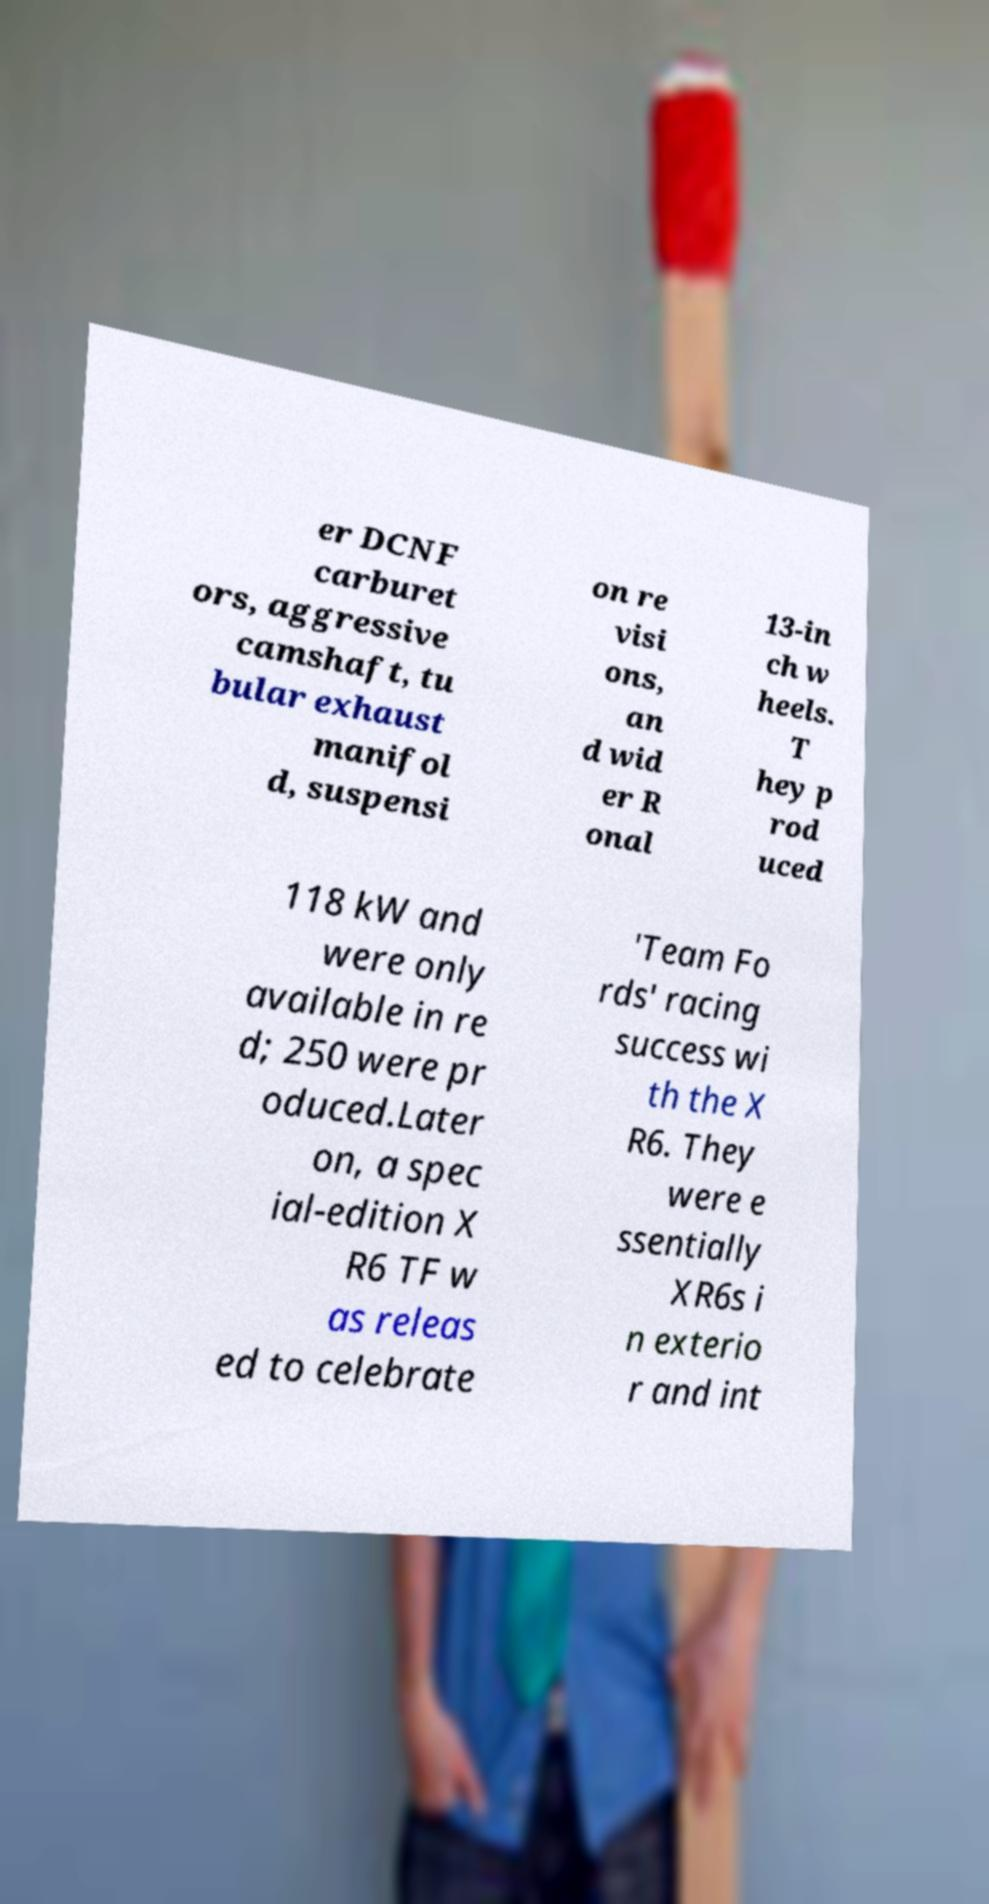For documentation purposes, I need the text within this image transcribed. Could you provide that? er DCNF carburet ors, aggressive camshaft, tu bular exhaust manifol d, suspensi on re visi ons, an d wid er R onal 13-in ch w heels. T hey p rod uced 118 kW and were only available in re d; 250 were pr oduced.Later on, a spec ial-edition X R6 TF w as releas ed to celebrate 'Team Fo rds' racing success wi th the X R6. They were e ssentially XR6s i n exterio r and int 